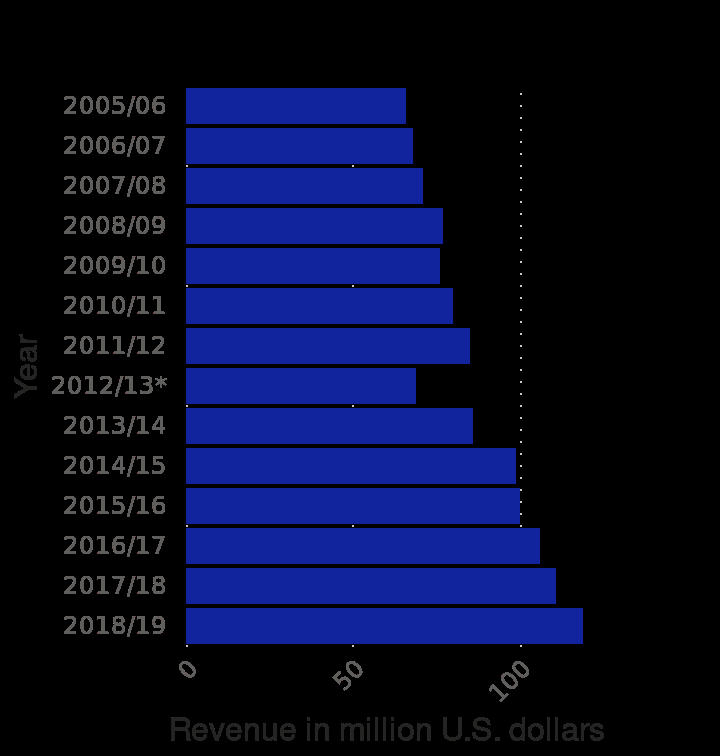<image>
What is the range of the x-axis in the bar diagram? The range of the x-axis in the bar diagram is from 0 to 100 million U.S. dollars. When did the decrease in sales begin?  The decrease in sales began from 2018/2019. please describe the details of the chart This is a bar diagram named Revenue of the Columbus Blue Jackets from 2005/06 to 2018/19 (in million U.S. dollars). The x-axis plots Revenue in million U.S. dollars as linear scale of range 0 to 100 while the y-axis plots Year along categorical scale from 2005/06 to . 